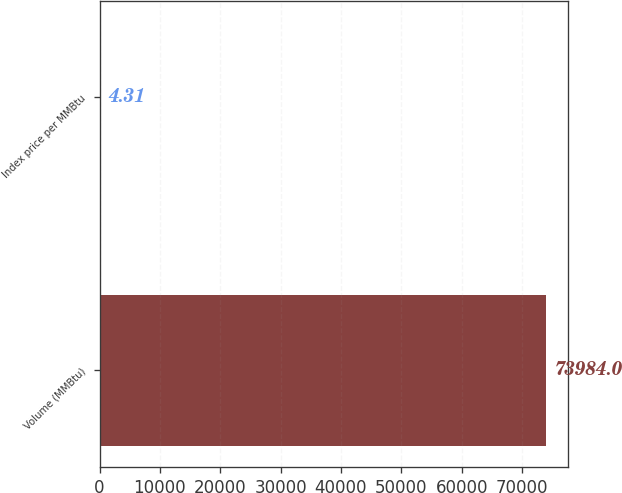Convert chart to OTSL. <chart><loc_0><loc_0><loc_500><loc_500><bar_chart><fcel>Volume (MMBtu)<fcel>Index price per MMBtu<nl><fcel>73984<fcel>4.31<nl></chart> 